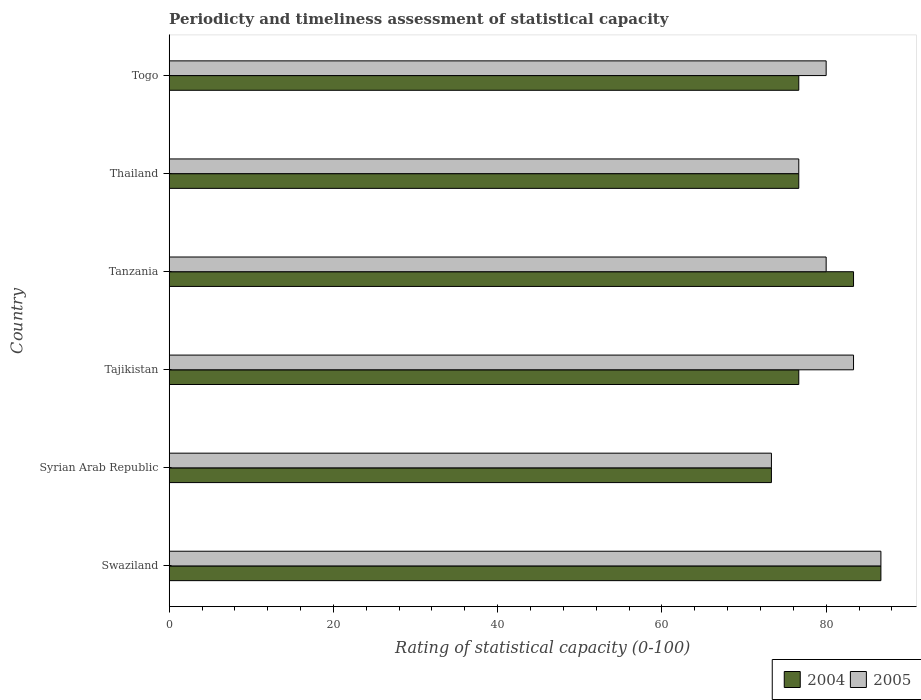How many groups of bars are there?
Your answer should be very brief. 6. How many bars are there on the 3rd tick from the bottom?
Give a very brief answer. 2. What is the label of the 4th group of bars from the top?
Provide a succinct answer. Tajikistan. In how many cases, is the number of bars for a given country not equal to the number of legend labels?
Keep it short and to the point. 0. What is the rating of statistical capacity in 2005 in Swaziland?
Provide a short and direct response. 86.67. Across all countries, what is the maximum rating of statistical capacity in 2004?
Ensure brevity in your answer.  86.67. Across all countries, what is the minimum rating of statistical capacity in 2004?
Give a very brief answer. 73.33. In which country was the rating of statistical capacity in 2004 maximum?
Your response must be concise. Swaziland. In which country was the rating of statistical capacity in 2004 minimum?
Give a very brief answer. Syrian Arab Republic. What is the total rating of statistical capacity in 2004 in the graph?
Make the answer very short. 473.33. What is the difference between the rating of statistical capacity in 2005 in Tanzania and that in Thailand?
Ensure brevity in your answer.  3.33. What is the difference between the rating of statistical capacity in 2004 and rating of statistical capacity in 2005 in Tanzania?
Provide a succinct answer. 3.33. In how many countries, is the rating of statistical capacity in 2005 greater than 28 ?
Make the answer very short. 6. What is the ratio of the rating of statistical capacity in 2004 in Syrian Arab Republic to that in Thailand?
Your answer should be very brief. 0.96. What is the difference between the highest and the second highest rating of statistical capacity in 2004?
Ensure brevity in your answer.  3.33. What is the difference between the highest and the lowest rating of statistical capacity in 2004?
Your response must be concise. 13.33. In how many countries, is the rating of statistical capacity in 2005 greater than the average rating of statistical capacity in 2005 taken over all countries?
Provide a succinct answer. 2. What does the 1st bar from the top in Syrian Arab Republic represents?
Make the answer very short. 2005. How many bars are there?
Ensure brevity in your answer.  12. How many countries are there in the graph?
Make the answer very short. 6. What is the difference between two consecutive major ticks on the X-axis?
Make the answer very short. 20. Does the graph contain grids?
Offer a terse response. No. How many legend labels are there?
Give a very brief answer. 2. What is the title of the graph?
Keep it short and to the point. Periodicty and timeliness assessment of statistical capacity. Does "2013" appear as one of the legend labels in the graph?
Offer a terse response. No. What is the label or title of the X-axis?
Make the answer very short. Rating of statistical capacity (0-100). What is the label or title of the Y-axis?
Offer a terse response. Country. What is the Rating of statistical capacity (0-100) of 2004 in Swaziland?
Your answer should be compact. 86.67. What is the Rating of statistical capacity (0-100) of 2005 in Swaziland?
Make the answer very short. 86.67. What is the Rating of statistical capacity (0-100) in 2004 in Syrian Arab Republic?
Your answer should be compact. 73.33. What is the Rating of statistical capacity (0-100) of 2005 in Syrian Arab Republic?
Give a very brief answer. 73.33. What is the Rating of statistical capacity (0-100) in 2004 in Tajikistan?
Your answer should be compact. 76.67. What is the Rating of statistical capacity (0-100) in 2005 in Tajikistan?
Give a very brief answer. 83.33. What is the Rating of statistical capacity (0-100) of 2004 in Tanzania?
Your answer should be compact. 83.33. What is the Rating of statistical capacity (0-100) of 2005 in Tanzania?
Keep it short and to the point. 80. What is the Rating of statistical capacity (0-100) of 2004 in Thailand?
Offer a terse response. 76.67. What is the Rating of statistical capacity (0-100) in 2005 in Thailand?
Offer a terse response. 76.67. What is the Rating of statistical capacity (0-100) in 2004 in Togo?
Keep it short and to the point. 76.67. Across all countries, what is the maximum Rating of statistical capacity (0-100) of 2004?
Your answer should be compact. 86.67. Across all countries, what is the maximum Rating of statistical capacity (0-100) of 2005?
Offer a very short reply. 86.67. Across all countries, what is the minimum Rating of statistical capacity (0-100) in 2004?
Your answer should be compact. 73.33. Across all countries, what is the minimum Rating of statistical capacity (0-100) of 2005?
Offer a terse response. 73.33. What is the total Rating of statistical capacity (0-100) in 2004 in the graph?
Keep it short and to the point. 473.33. What is the total Rating of statistical capacity (0-100) of 2005 in the graph?
Provide a succinct answer. 480. What is the difference between the Rating of statistical capacity (0-100) of 2004 in Swaziland and that in Syrian Arab Republic?
Ensure brevity in your answer.  13.33. What is the difference between the Rating of statistical capacity (0-100) in 2005 in Swaziland and that in Syrian Arab Republic?
Ensure brevity in your answer.  13.33. What is the difference between the Rating of statistical capacity (0-100) in 2004 in Swaziland and that in Tanzania?
Give a very brief answer. 3.33. What is the difference between the Rating of statistical capacity (0-100) in 2005 in Swaziland and that in Thailand?
Offer a terse response. 10. What is the difference between the Rating of statistical capacity (0-100) of 2005 in Swaziland and that in Togo?
Give a very brief answer. 6.67. What is the difference between the Rating of statistical capacity (0-100) of 2005 in Syrian Arab Republic and that in Tanzania?
Offer a terse response. -6.67. What is the difference between the Rating of statistical capacity (0-100) of 2005 in Syrian Arab Republic and that in Thailand?
Make the answer very short. -3.33. What is the difference between the Rating of statistical capacity (0-100) of 2005 in Syrian Arab Republic and that in Togo?
Provide a short and direct response. -6.67. What is the difference between the Rating of statistical capacity (0-100) in 2004 in Tajikistan and that in Tanzania?
Keep it short and to the point. -6.67. What is the difference between the Rating of statistical capacity (0-100) in 2005 in Tajikistan and that in Tanzania?
Keep it short and to the point. 3.33. What is the difference between the Rating of statistical capacity (0-100) in 2005 in Tajikistan and that in Thailand?
Offer a terse response. 6.67. What is the difference between the Rating of statistical capacity (0-100) in 2004 in Tanzania and that in Thailand?
Ensure brevity in your answer.  6.67. What is the difference between the Rating of statistical capacity (0-100) of 2005 in Tanzania and that in Thailand?
Your answer should be very brief. 3.33. What is the difference between the Rating of statistical capacity (0-100) in 2005 in Tanzania and that in Togo?
Make the answer very short. 0. What is the difference between the Rating of statistical capacity (0-100) of 2004 in Thailand and that in Togo?
Your answer should be compact. 0. What is the difference between the Rating of statistical capacity (0-100) of 2005 in Thailand and that in Togo?
Make the answer very short. -3.33. What is the difference between the Rating of statistical capacity (0-100) of 2004 in Swaziland and the Rating of statistical capacity (0-100) of 2005 in Syrian Arab Republic?
Provide a succinct answer. 13.33. What is the difference between the Rating of statistical capacity (0-100) in 2004 in Swaziland and the Rating of statistical capacity (0-100) in 2005 in Tanzania?
Your response must be concise. 6.67. What is the difference between the Rating of statistical capacity (0-100) in 2004 in Swaziland and the Rating of statistical capacity (0-100) in 2005 in Thailand?
Provide a succinct answer. 10. What is the difference between the Rating of statistical capacity (0-100) in 2004 in Syrian Arab Republic and the Rating of statistical capacity (0-100) in 2005 in Tajikistan?
Ensure brevity in your answer.  -10. What is the difference between the Rating of statistical capacity (0-100) of 2004 in Syrian Arab Republic and the Rating of statistical capacity (0-100) of 2005 in Tanzania?
Keep it short and to the point. -6.67. What is the difference between the Rating of statistical capacity (0-100) of 2004 in Syrian Arab Republic and the Rating of statistical capacity (0-100) of 2005 in Togo?
Provide a succinct answer. -6.67. What is the difference between the Rating of statistical capacity (0-100) in 2004 in Tajikistan and the Rating of statistical capacity (0-100) in 2005 in Tanzania?
Your answer should be very brief. -3.33. What is the difference between the Rating of statistical capacity (0-100) of 2004 in Tajikistan and the Rating of statistical capacity (0-100) of 2005 in Togo?
Keep it short and to the point. -3.33. What is the difference between the Rating of statistical capacity (0-100) in 2004 in Tanzania and the Rating of statistical capacity (0-100) in 2005 in Thailand?
Your answer should be very brief. 6.67. What is the average Rating of statistical capacity (0-100) of 2004 per country?
Keep it short and to the point. 78.89. What is the difference between the Rating of statistical capacity (0-100) in 2004 and Rating of statistical capacity (0-100) in 2005 in Tajikistan?
Keep it short and to the point. -6.67. What is the difference between the Rating of statistical capacity (0-100) in 2004 and Rating of statistical capacity (0-100) in 2005 in Thailand?
Give a very brief answer. 0. What is the difference between the Rating of statistical capacity (0-100) in 2004 and Rating of statistical capacity (0-100) in 2005 in Togo?
Your answer should be compact. -3.33. What is the ratio of the Rating of statistical capacity (0-100) in 2004 in Swaziland to that in Syrian Arab Republic?
Provide a short and direct response. 1.18. What is the ratio of the Rating of statistical capacity (0-100) of 2005 in Swaziland to that in Syrian Arab Republic?
Give a very brief answer. 1.18. What is the ratio of the Rating of statistical capacity (0-100) in 2004 in Swaziland to that in Tajikistan?
Give a very brief answer. 1.13. What is the ratio of the Rating of statistical capacity (0-100) of 2004 in Swaziland to that in Tanzania?
Your answer should be very brief. 1.04. What is the ratio of the Rating of statistical capacity (0-100) of 2004 in Swaziland to that in Thailand?
Your answer should be compact. 1.13. What is the ratio of the Rating of statistical capacity (0-100) in 2005 in Swaziland to that in Thailand?
Keep it short and to the point. 1.13. What is the ratio of the Rating of statistical capacity (0-100) of 2004 in Swaziland to that in Togo?
Provide a succinct answer. 1.13. What is the ratio of the Rating of statistical capacity (0-100) of 2005 in Swaziland to that in Togo?
Provide a succinct answer. 1.08. What is the ratio of the Rating of statistical capacity (0-100) in 2004 in Syrian Arab Republic to that in Tajikistan?
Give a very brief answer. 0.96. What is the ratio of the Rating of statistical capacity (0-100) of 2004 in Syrian Arab Republic to that in Thailand?
Provide a short and direct response. 0.96. What is the ratio of the Rating of statistical capacity (0-100) of 2005 in Syrian Arab Republic to that in Thailand?
Provide a succinct answer. 0.96. What is the ratio of the Rating of statistical capacity (0-100) of 2004 in Syrian Arab Republic to that in Togo?
Your answer should be very brief. 0.96. What is the ratio of the Rating of statistical capacity (0-100) in 2004 in Tajikistan to that in Tanzania?
Offer a very short reply. 0.92. What is the ratio of the Rating of statistical capacity (0-100) of 2005 in Tajikistan to that in Tanzania?
Your response must be concise. 1.04. What is the ratio of the Rating of statistical capacity (0-100) in 2004 in Tajikistan to that in Thailand?
Offer a terse response. 1. What is the ratio of the Rating of statistical capacity (0-100) of 2005 in Tajikistan to that in Thailand?
Offer a terse response. 1.09. What is the ratio of the Rating of statistical capacity (0-100) in 2004 in Tajikistan to that in Togo?
Provide a succinct answer. 1. What is the ratio of the Rating of statistical capacity (0-100) in 2005 in Tajikistan to that in Togo?
Your answer should be very brief. 1.04. What is the ratio of the Rating of statistical capacity (0-100) in 2004 in Tanzania to that in Thailand?
Offer a very short reply. 1.09. What is the ratio of the Rating of statistical capacity (0-100) in 2005 in Tanzania to that in Thailand?
Keep it short and to the point. 1.04. What is the ratio of the Rating of statistical capacity (0-100) of 2004 in Tanzania to that in Togo?
Offer a terse response. 1.09. What is the ratio of the Rating of statistical capacity (0-100) of 2005 in Tanzania to that in Togo?
Ensure brevity in your answer.  1. What is the ratio of the Rating of statistical capacity (0-100) of 2004 in Thailand to that in Togo?
Offer a terse response. 1. What is the difference between the highest and the second highest Rating of statistical capacity (0-100) of 2004?
Keep it short and to the point. 3.33. What is the difference between the highest and the lowest Rating of statistical capacity (0-100) in 2004?
Provide a short and direct response. 13.33. What is the difference between the highest and the lowest Rating of statistical capacity (0-100) in 2005?
Your response must be concise. 13.33. 